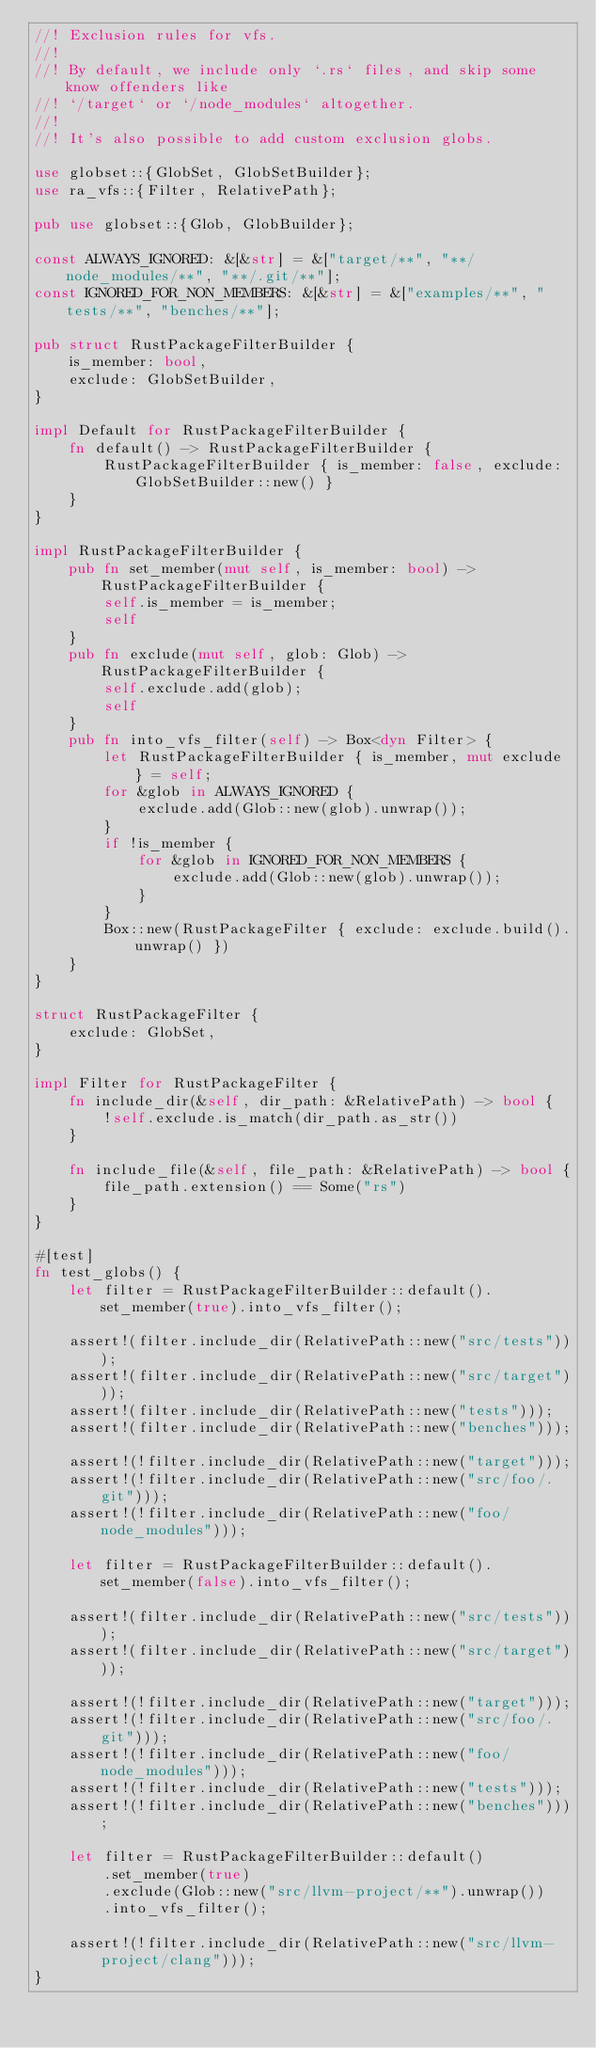<code> <loc_0><loc_0><loc_500><loc_500><_Rust_>//! Exclusion rules for vfs.
//!
//! By default, we include only `.rs` files, and skip some know offenders like
//! `/target` or `/node_modules` altogether.
//!
//! It's also possible to add custom exclusion globs.

use globset::{GlobSet, GlobSetBuilder};
use ra_vfs::{Filter, RelativePath};

pub use globset::{Glob, GlobBuilder};

const ALWAYS_IGNORED: &[&str] = &["target/**", "**/node_modules/**", "**/.git/**"];
const IGNORED_FOR_NON_MEMBERS: &[&str] = &["examples/**", "tests/**", "benches/**"];

pub struct RustPackageFilterBuilder {
    is_member: bool,
    exclude: GlobSetBuilder,
}

impl Default for RustPackageFilterBuilder {
    fn default() -> RustPackageFilterBuilder {
        RustPackageFilterBuilder { is_member: false, exclude: GlobSetBuilder::new() }
    }
}

impl RustPackageFilterBuilder {
    pub fn set_member(mut self, is_member: bool) -> RustPackageFilterBuilder {
        self.is_member = is_member;
        self
    }
    pub fn exclude(mut self, glob: Glob) -> RustPackageFilterBuilder {
        self.exclude.add(glob);
        self
    }
    pub fn into_vfs_filter(self) -> Box<dyn Filter> {
        let RustPackageFilterBuilder { is_member, mut exclude } = self;
        for &glob in ALWAYS_IGNORED {
            exclude.add(Glob::new(glob).unwrap());
        }
        if !is_member {
            for &glob in IGNORED_FOR_NON_MEMBERS {
                exclude.add(Glob::new(glob).unwrap());
            }
        }
        Box::new(RustPackageFilter { exclude: exclude.build().unwrap() })
    }
}

struct RustPackageFilter {
    exclude: GlobSet,
}

impl Filter for RustPackageFilter {
    fn include_dir(&self, dir_path: &RelativePath) -> bool {
        !self.exclude.is_match(dir_path.as_str())
    }

    fn include_file(&self, file_path: &RelativePath) -> bool {
        file_path.extension() == Some("rs")
    }
}

#[test]
fn test_globs() {
    let filter = RustPackageFilterBuilder::default().set_member(true).into_vfs_filter();

    assert!(filter.include_dir(RelativePath::new("src/tests")));
    assert!(filter.include_dir(RelativePath::new("src/target")));
    assert!(filter.include_dir(RelativePath::new("tests")));
    assert!(filter.include_dir(RelativePath::new("benches")));

    assert!(!filter.include_dir(RelativePath::new("target")));
    assert!(!filter.include_dir(RelativePath::new("src/foo/.git")));
    assert!(!filter.include_dir(RelativePath::new("foo/node_modules")));

    let filter = RustPackageFilterBuilder::default().set_member(false).into_vfs_filter();

    assert!(filter.include_dir(RelativePath::new("src/tests")));
    assert!(filter.include_dir(RelativePath::new("src/target")));

    assert!(!filter.include_dir(RelativePath::new("target")));
    assert!(!filter.include_dir(RelativePath::new("src/foo/.git")));
    assert!(!filter.include_dir(RelativePath::new("foo/node_modules")));
    assert!(!filter.include_dir(RelativePath::new("tests")));
    assert!(!filter.include_dir(RelativePath::new("benches")));

    let filter = RustPackageFilterBuilder::default()
        .set_member(true)
        .exclude(Glob::new("src/llvm-project/**").unwrap())
        .into_vfs_filter();

    assert!(!filter.include_dir(RelativePath::new("src/llvm-project/clang")));
}
</code> 